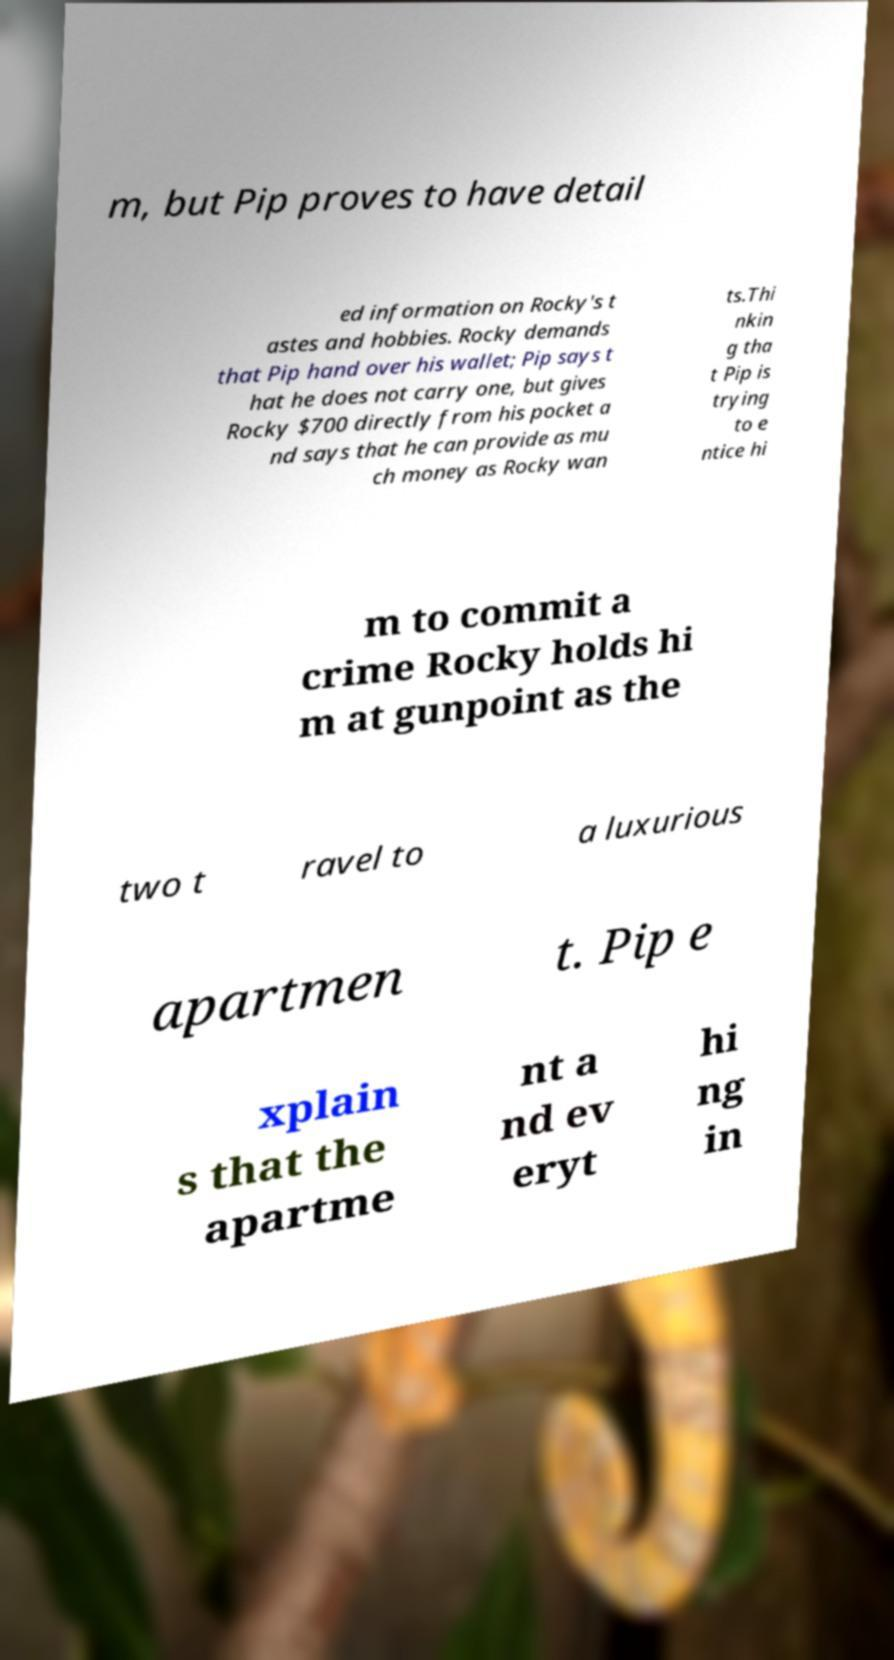For documentation purposes, I need the text within this image transcribed. Could you provide that? m, but Pip proves to have detail ed information on Rocky's t astes and hobbies. Rocky demands that Pip hand over his wallet; Pip says t hat he does not carry one, but gives Rocky $700 directly from his pocket a nd says that he can provide as mu ch money as Rocky wan ts.Thi nkin g tha t Pip is trying to e ntice hi m to commit a crime Rocky holds hi m at gunpoint as the two t ravel to a luxurious apartmen t. Pip e xplain s that the apartme nt a nd ev eryt hi ng in 